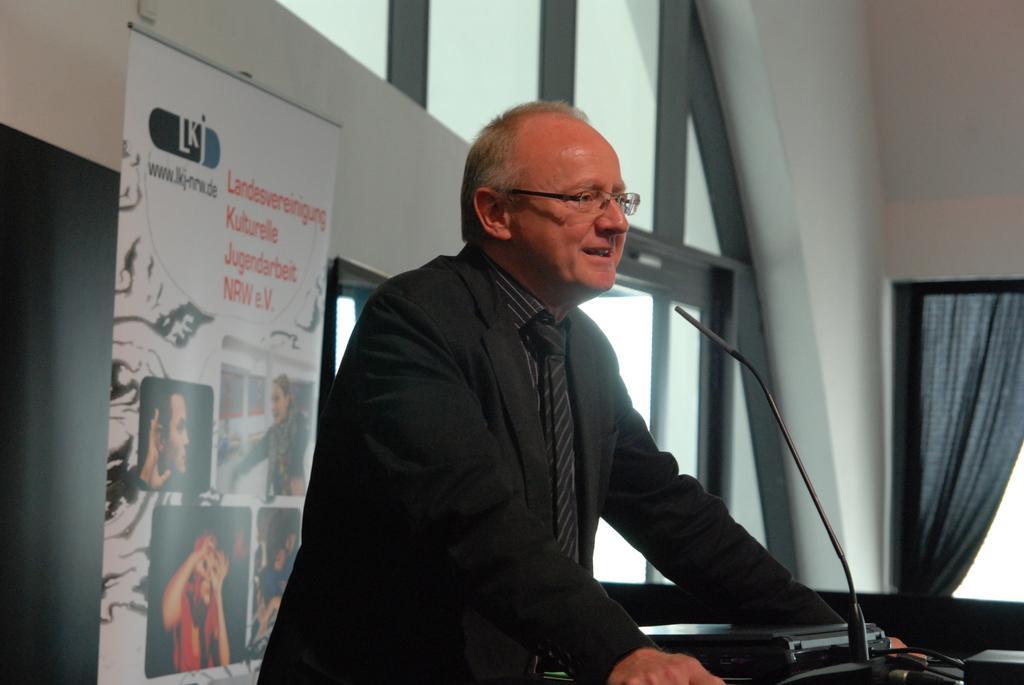Could you give a brief overview of what you see in this image? In this image there is a person standing in front of the table. On the table there is a mic and few other objects, behind the person there is a banner with some images and text on it, there is a wall with windows and there are curtains. 